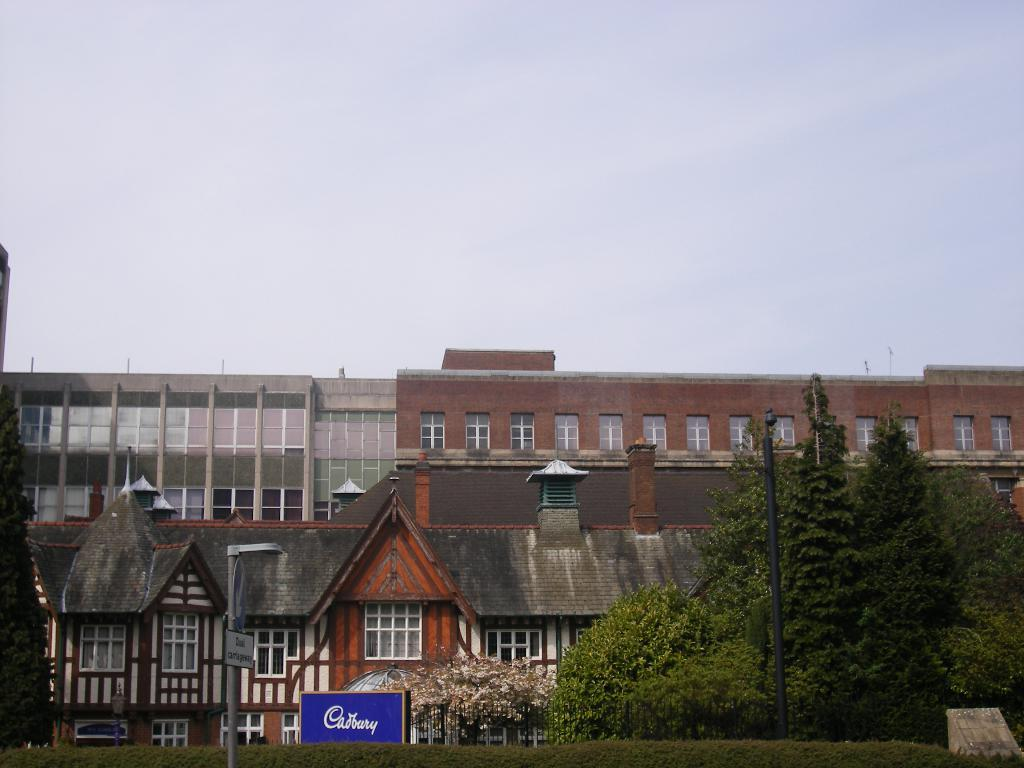What can be seen in the background of the image? There are buildings in the background of the image. What type of vegetation is on the right side of the image? There are trees on the right side of the image. What is visible in the image besides the buildings and trees? The sky is visible in the image. What can be observed in the sky? Clouds are present in the sky. What advertisement can be seen on the trees in the image? There is no advertisement present on the trees in the image; only trees are visible. How many police officers are visible in the image? There are no police officers present in the image. 